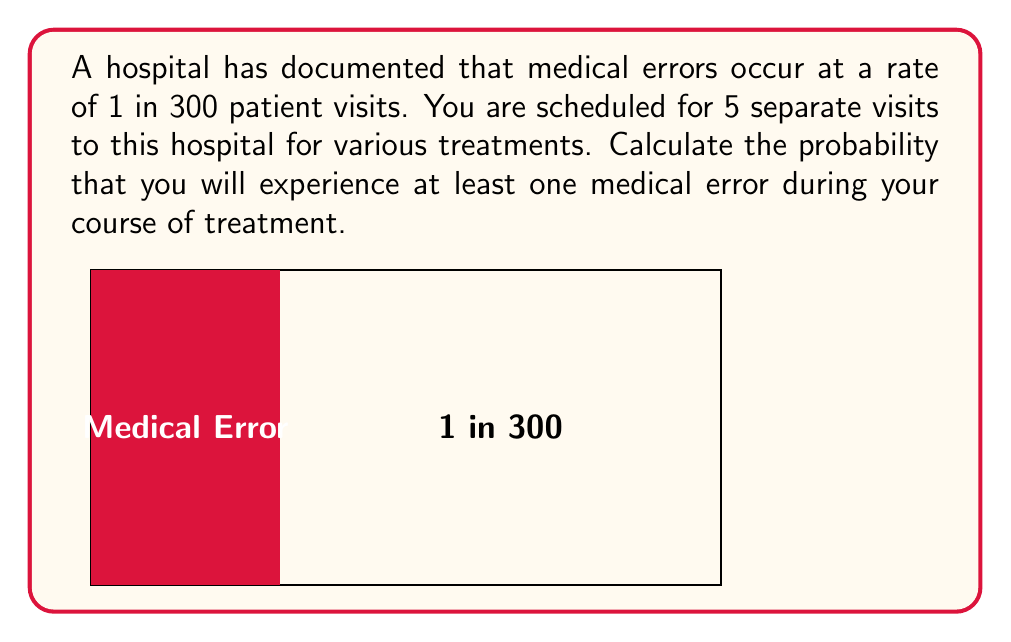Give your solution to this math problem. Let's approach this step-by-step:

1) First, let's define our probability:
   $p$ = probability of a medical error occurring in a single visit
   $p = \frac{1}{300} = 0.00333$

2) We want to find the probability of at least one error in 5 visits. It's easier to calculate the probability of no errors occurring and then subtract that from 1.

3) The probability of no error in a single visit is:
   $1 - p = 1 - 0.00333 = 0.99667$

4) For no errors to occur in all 5 visits, we need this to happen 5 times in a row. We can calculate this using the multiplication rule of probability:
   $P(\text{no errors in 5 visits}) = (0.99667)^5 = 0.98345$

5) Therefore, the probability of at least one error in 5 visits is:
   $P(\text{at least one error}) = 1 - P(\text{no errors})$
   $= 1 - 0.98345 = 0.01655$

6) Converting to a percentage:
   $0.01655 \times 100\% = 1.655\%$
Answer: 1.655% 